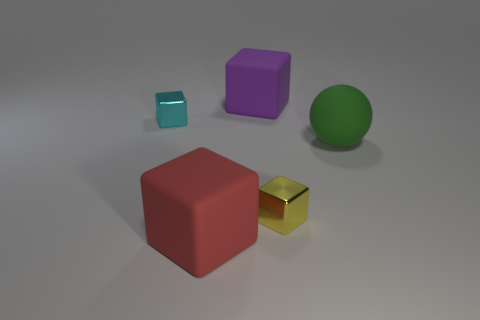How many big matte things are in front of the big cube that is in front of the cube that is to the left of the red rubber cube? 0 